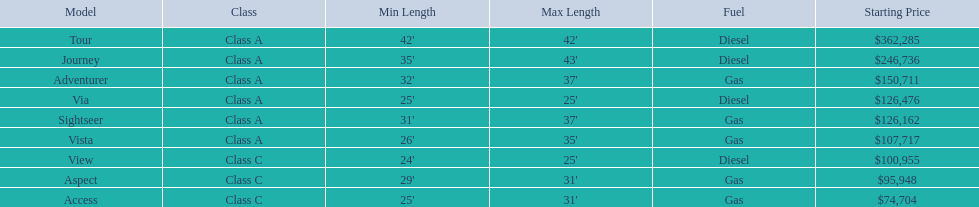What is the name of the top priced winnebago model? Tour. 